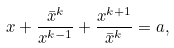Convert formula to latex. <formula><loc_0><loc_0><loc_500><loc_500>x + \frac { \bar { x } ^ { k } } { x ^ { k - 1 } } + \frac { x ^ { k + 1 } } { \bar { x } ^ { k } } = a ,</formula> 